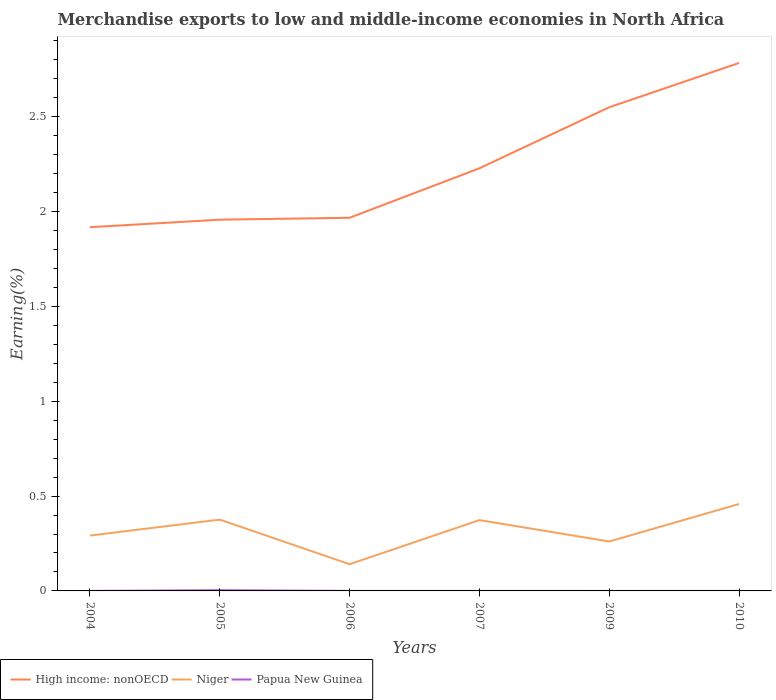Is the number of lines equal to the number of legend labels?
Ensure brevity in your answer.  Yes. Across all years, what is the maximum percentage of amount earned from merchandise exports in High income: nonOECD?
Offer a terse response. 1.92. What is the total percentage of amount earned from merchandise exports in High income: nonOECD in the graph?
Your response must be concise. -0.87. What is the difference between the highest and the second highest percentage of amount earned from merchandise exports in Papua New Guinea?
Your answer should be compact. 0. What is the difference between the highest and the lowest percentage of amount earned from merchandise exports in Niger?
Provide a short and direct response. 3. Is the percentage of amount earned from merchandise exports in Niger strictly greater than the percentage of amount earned from merchandise exports in High income: nonOECD over the years?
Provide a short and direct response. Yes. How many years are there in the graph?
Make the answer very short. 6. Does the graph contain any zero values?
Your answer should be very brief. No. Does the graph contain grids?
Your answer should be very brief. No. How are the legend labels stacked?
Keep it short and to the point. Horizontal. What is the title of the graph?
Give a very brief answer. Merchandise exports to low and middle-income economies in North Africa. What is the label or title of the Y-axis?
Ensure brevity in your answer.  Earning(%). What is the Earning(%) of High income: nonOECD in 2004?
Your answer should be compact. 1.92. What is the Earning(%) of Niger in 2004?
Your response must be concise. 0.29. What is the Earning(%) in Papua New Guinea in 2004?
Keep it short and to the point. 9.77440522683759e-5. What is the Earning(%) of High income: nonOECD in 2005?
Your answer should be very brief. 1.96. What is the Earning(%) of Niger in 2005?
Your response must be concise. 0.38. What is the Earning(%) of Papua New Guinea in 2005?
Your response must be concise. 0. What is the Earning(%) of High income: nonOECD in 2006?
Ensure brevity in your answer.  1.97. What is the Earning(%) in Niger in 2006?
Make the answer very short. 0.14. What is the Earning(%) in Papua New Guinea in 2006?
Offer a very short reply. 5.687845223438829e-5. What is the Earning(%) of High income: nonOECD in 2007?
Offer a terse response. 2.23. What is the Earning(%) in Niger in 2007?
Keep it short and to the point. 0.37. What is the Earning(%) in Papua New Guinea in 2007?
Your answer should be very brief. 7.101729207290841e-5. What is the Earning(%) of High income: nonOECD in 2009?
Offer a terse response. 2.55. What is the Earning(%) of Niger in 2009?
Your response must be concise. 0.26. What is the Earning(%) of Papua New Guinea in 2009?
Your answer should be compact. 2.30290582188182e-5. What is the Earning(%) in High income: nonOECD in 2010?
Your answer should be very brief. 2.78. What is the Earning(%) of Niger in 2010?
Offer a very short reply. 0.46. What is the Earning(%) in Papua New Guinea in 2010?
Offer a very short reply. 3.96869620498379e-5. Across all years, what is the maximum Earning(%) of High income: nonOECD?
Your response must be concise. 2.78. Across all years, what is the maximum Earning(%) of Niger?
Your answer should be very brief. 0.46. Across all years, what is the maximum Earning(%) in Papua New Guinea?
Offer a very short reply. 0. Across all years, what is the minimum Earning(%) in High income: nonOECD?
Your answer should be compact. 1.92. Across all years, what is the minimum Earning(%) of Niger?
Give a very brief answer. 0.14. Across all years, what is the minimum Earning(%) of Papua New Guinea?
Provide a succinct answer. 2.30290582188182e-5. What is the total Earning(%) in High income: nonOECD in the graph?
Provide a succinct answer. 13.4. What is the total Earning(%) of Niger in the graph?
Your answer should be compact. 1.9. What is the total Earning(%) of Papua New Guinea in the graph?
Give a very brief answer. 0. What is the difference between the Earning(%) in High income: nonOECD in 2004 and that in 2005?
Keep it short and to the point. -0.04. What is the difference between the Earning(%) in Niger in 2004 and that in 2005?
Ensure brevity in your answer.  -0.08. What is the difference between the Earning(%) in Papua New Guinea in 2004 and that in 2005?
Make the answer very short. -0. What is the difference between the Earning(%) of High income: nonOECD in 2004 and that in 2006?
Give a very brief answer. -0.05. What is the difference between the Earning(%) in Niger in 2004 and that in 2006?
Provide a short and direct response. 0.15. What is the difference between the Earning(%) of High income: nonOECD in 2004 and that in 2007?
Your answer should be compact. -0.31. What is the difference between the Earning(%) of Niger in 2004 and that in 2007?
Provide a succinct answer. -0.08. What is the difference between the Earning(%) of Papua New Guinea in 2004 and that in 2007?
Provide a succinct answer. 0. What is the difference between the Earning(%) of High income: nonOECD in 2004 and that in 2009?
Offer a terse response. -0.63. What is the difference between the Earning(%) in Niger in 2004 and that in 2009?
Your answer should be very brief. 0.03. What is the difference between the Earning(%) in High income: nonOECD in 2004 and that in 2010?
Your answer should be very brief. -0.87. What is the difference between the Earning(%) of Niger in 2004 and that in 2010?
Offer a terse response. -0.17. What is the difference between the Earning(%) of High income: nonOECD in 2005 and that in 2006?
Provide a succinct answer. -0.01. What is the difference between the Earning(%) in Niger in 2005 and that in 2006?
Give a very brief answer. 0.24. What is the difference between the Earning(%) in Papua New Guinea in 2005 and that in 2006?
Your answer should be compact. 0. What is the difference between the Earning(%) in High income: nonOECD in 2005 and that in 2007?
Your response must be concise. -0.27. What is the difference between the Earning(%) of Niger in 2005 and that in 2007?
Offer a very short reply. 0. What is the difference between the Earning(%) in Papua New Guinea in 2005 and that in 2007?
Keep it short and to the point. 0. What is the difference between the Earning(%) in High income: nonOECD in 2005 and that in 2009?
Ensure brevity in your answer.  -0.59. What is the difference between the Earning(%) in Niger in 2005 and that in 2009?
Your response must be concise. 0.12. What is the difference between the Earning(%) in Papua New Guinea in 2005 and that in 2009?
Offer a terse response. 0. What is the difference between the Earning(%) in High income: nonOECD in 2005 and that in 2010?
Ensure brevity in your answer.  -0.83. What is the difference between the Earning(%) of Niger in 2005 and that in 2010?
Make the answer very short. -0.08. What is the difference between the Earning(%) of Papua New Guinea in 2005 and that in 2010?
Your answer should be very brief. 0. What is the difference between the Earning(%) in High income: nonOECD in 2006 and that in 2007?
Provide a short and direct response. -0.26. What is the difference between the Earning(%) in Niger in 2006 and that in 2007?
Provide a short and direct response. -0.23. What is the difference between the Earning(%) in Papua New Guinea in 2006 and that in 2007?
Ensure brevity in your answer.  -0. What is the difference between the Earning(%) in High income: nonOECD in 2006 and that in 2009?
Your response must be concise. -0.58. What is the difference between the Earning(%) in Niger in 2006 and that in 2009?
Offer a very short reply. -0.12. What is the difference between the Earning(%) of High income: nonOECD in 2006 and that in 2010?
Provide a succinct answer. -0.82. What is the difference between the Earning(%) in Niger in 2006 and that in 2010?
Make the answer very short. -0.32. What is the difference between the Earning(%) in High income: nonOECD in 2007 and that in 2009?
Offer a terse response. -0.32. What is the difference between the Earning(%) of Niger in 2007 and that in 2009?
Ensure brevity in your answer.  0.11. What is the difference between the Earning(%) of High income: nonOECD in 2007 and that in 2010?
Offer a terse response. -0.56. What is the difference between the Earning(%) in Niger in 2007 and that in 2010?
Your response must be concise. -0.08. What is the difference between the Earning(%) in Papua New Guinea in 2007 and that in 2010?
Provide a succinct answer. 0. What is the difference between the Earning(%) in High income: nonOECD in 2009 and that in 2010?
Offer a terse response. -0.23. What is the difference between the Earning(%) of Niger in 2009 and that in 2010?
Offer a very short reply. -0.2. What is the difference between the Earning(%) of High income: nonOECD in 2004 and the Earning(%) of Niger in 2005?
Ensure brevity in your answer.  1.54. What is the difference between the Earning(%) of High income: nonOECD in 2004 and the Earning(%) of Papua New Guinea in 2005?
Your response must be concise. 1.91. What is the difference between the Earning(%) in Niger in 2004 and the Earning(%) in Papua New Guinea in 2005?
Keep it short and to the point. 0.29. What is the difference between the Earning(%) in High income: nonOECD in 2004 and the Earning(%) in Niger in 2006?
Provide a succinct answer. 1.78. What is the difference between the Earning(%) of High income: nonOECD in 2004 and the Earning(%) of Papua New Guinea in 2006?
Ensure brevity in your answer.  1.92. What is the difference between the Earning(%) of Niger in 2004 and the Earning(%) of Papua New Guinea in 2006?
Your response must be concise. 0.29. What is the difference between the Earning(%) in High income: nonOECD in 2004 and the Earning(%) in Niger in 2007?
Make the answer very short. 1.54. What is the difference between the Earning(%) of High income: nonOECD in 2004 and the Earning(%) of Papua New Guinea in 2007?
Your answer should be very brief. 1.92. What is the difference between the Earning(%) of Niger in 2004 and the Earning(%) of Papua New Guinea in 2007?
Ensure brevity in your answer.  0.29. What is the difference between the Earning(%) in High income: nonOECD in 2004 and the Earning(%) in Niger in 2009?
Offer a very short reply. 1.66. What is the difference between the Earning(%) in High income: nonOECD in 2004 and the Earning(%) in Papua New Guinea in 2009?
Keep it short and to the point. 1.92. What is the difference between the Earning(%) of Niger in 2004 and the Earning(%) of Papua New Guinea in 2009?
Make the answer very short. 0.29. What is the difference between the Earning(%) of High income: nonOECD in 2004 and the Earning(%) of Niger in 2010?
Your response must be concise. 1.46. What is the difference between the Earning(%) of High income: nonOECD in 2004 and the Earning(%) of Papua New Guinea in 2010?
Provide a succinct answer. 1.92. What is the difference between the Earning(%) of Niger in 2004 and the Earning(%) of Papua New Guinea in 2010?
Your response must be concise. 0.29. What is the difference between the Earning(%) of High income: nonOECD in 2005 and the Earning(%) of Niger in 2006?
Your answer should be very brief. 1.82. What is the difference between the Earning(%) in High income: nonOECD in 2005 and the Earning(%) in Papua New Guinea in 2006?
Your answer should be compact. 1.96. What is the difference between the Earning(%) in Niger in 2005 and the Earning(%) in Papua New Guinea in 2006?
Ensure brevity in your answer.  0.38. What is the difference between the Earning(%) of High income: nonOECD in 2005 and the Earning(%) of Niger in 2007?
Provide a short and direct response. 1.58. What is the difference between the Earning(%) in High income: nonOECD in 2005 and the Earning(%) in Papua New Guinea in 2007?
Keep it short and to the point. 1.96. What is the difference between the Earning(%) in Niger in 2005 and the Earning(%) in Papua New Guinea in 2007?
Your answer should be compact. 0.38. What is the difference between the Earning(%) of High income: nonOECD in 2005 and the Earning(%) of Niger in 2009?
Offer a very short reply. 1.7. What is the difference between the Earning(%) of High income: nonOECD in 2005 and the Earning(%) of Papua New Guinea in 2009?
Provide a short and direct response. 1.96. What is the difference between the Earning(%) in Niger in 2005 and the Earning(%) in Papua New Guinea in 2009?
Offer a terse response. 0.38. What is the difference between the Earning(%) in High income: nonOECD in 2005 and the Earning(%) in Niger in 2010?
Provide a succinct answer. 1.5. What is the difference between the Earning(%) in High income: nonOECD in 2005 and the Earning(%) in Papua New Guinea in 2010?
Make the answer very short. 1.96. What is the difference between the Earning(%) in Niger in 2005 and the Earning(%) in Papua New Guinea in 2010?
Your answer should be very brief. 0.38. What is the difference between the Earning(%) in High income: nonOECD in 2006 and the Earning(%) in Niger in 2007?
Give a very brief answer. 1.59. What is the difference between the Earning(%) of High income: nonOECD in 2006 and the Earning(%) of Papua New Guinea in 2007?
Provide a succinct answer. 1.97. What is the difference between the Earning(%) of Niger in 2006 and the Earning(%) of Papua New Guinea in 2007?
Offer a terse response. 0.14. What is the difference between the Earning(%) in High income: nonOECD in 2006 and the Earning(%) in Niger in 2009?
Ensure brevity in your answer.  1.71. What is the difference between the Earning(%) in High income: nonOECD in 2006 and the Earning(%) in Papua New Guinea in 2009?
Keep it short and to the point. 1.97. What is the difference between the Earning(%) of Niger in 2006 and the Earning(%) of Papua New Guinea in 2009?
Offer a terse response. 0.14. What is the difference between the Earning(%) in High income: nonOECD in 2006 and the Earning(%) in Niger in 2010?
Give a very brief answer. 1.51. What is the difference between the Earning(%) in High income: nonOECD in 2006 and the Earning(%) in Papua New Guinea in 2010?
Offer a very short reply. 1.97. What is the difference between the Earning(%) in Niger in 2006 and the Earning(%) in Papua New Guinea in 2010?
Give a very brief answer. 0.14. What is the difference between the Earning(%) in High income: nonOECD in 2007 and the Earning(%) in Niger in 2009?
Offer a terse response. 1.97. What is the difference between the Earning(%) of High income: nonOECD in 2007 and the Earning(%) of Papua New Guinea in 2009?
Make the answer very short. 2.23. What is the difference between the Earning(%) in Niger in 2007 and the Earning(%) in Papua New Guinea in 2009?
Ensure brevity in your answer.  0.37. What is the difference between the Earning(%) in High income: nonOECD in 2007 and the Earning(%) in Niger in 2010?
Offer a terse response. 1.77. What is the difference between the Earning(%) of High income: nonOECD in 2007 and the Earning(%) of Papua New Guinea in 2010?
Keep it short and to the point. 2.23. What is the difference between the Earning(%) in Niger in 2007 and the Earning(%) in Papua New Guinea in 2010?
Provide a short and direct response. 0.37. What is the difference between the Earning(%) of High income: nonOECD in 2009 and the Earning(%) of Niger in 2010?
Your response must be concise. 2.09. What is the difference between the Earning(%) in High income: nonOECD in 2009 and the Earning(%) in Papua New Guinea in 2010?
Your response must be concise. 2.55. What is the difference between the Earning(%) in Niger in 2009 and the Earning(%) in Papua New Guinea in 2010?
Make the answer very short. 0.26. What is the average Earning(%) of High income: nonOECD per year?
Offer a terse response. 2.23. What is the average Earning(%) in Niger per year?
Provide a short and direct response. 0.32. What is the average Earning(%) in Papua New Guinea per year?
Provide a short and direct response. 0. In the year 2004, what is the difference between the Earning(%) of High income: nonOECD and Earning(%) of Niger?
Give a very brief answer. 1.63. In the year 2004, what is the difference between the Earning(%) in High income: nonOECD and Earning(%) in Papua New Guinea?
Give a very brief answer. 1.92. In the year 2004, what is the difference between the Earning(%) in Niger and Earning(%) in Papua New Guinea?
Ensure brevity in your answer.  0.29. In the year 2005, what is the difference between the Earning(%) of High income: nonOECD and Earning(%) of Niger?
Your answer should be compact. 1.58. In the year 2005, what is the difference between the Earning(%) of High income: nonOECD and Earning(%) of Papua New Guinea?
Provide a short and direct response. 1.95. In the year 2005, what is the difference between the Earning(%) in Niger and Earning(%) in Papua New Guinea?
Make the answer very short. 0.37. In the year 2006, what is the difference between the Earning(%) of High income: nonOECD and Earning(%) of Niger?
Your answer should be very brief. 1.83. In the year 2006, what is the difference between the Earning(%) of High income: nonOECD and Earning(%) of Papua New Guinea?
Provide a succinct answer. 1.97. In the year 2006, what is the difference between the Earning(%) of Niger and Earning(%) of Papua New Guinea?
Provide a succinct answer. 0.14. In the year 2007, what is the difference between the Earning(%) of High income: nonOECD and Earning(%) of Niger?
Provide a succinct answer. 1.85. In the year 2007, what is the difference between the Earning(%) of High income: nonOECD and Earning(%) of Papua New Guinea?
Ensure brevity in your answer.  2.23. In the year 2007, what is the difference between the Earning(%) of Niger and Earning(%) of Papua New Guinea?
Provide a succinct answer. 0.37. In the year 2009, what is the difference between the Earning(%) in High income: nonOECD and Earning(%) in Niger?
Provide a short and direct response. 2.29. In the year 2009, what is the difference between the Earning(%) in High income: nonOECD and Earning(%) in Papua New Guinea?
Your answer should be compact. 2.55. In the year 2009, what is the difference between the Earning(%) of Niger and Earning(%) of Papua New Guinea?
Your response must be concise. 0.26. In the year 2010, what is the difference between the Earning(%) in High income: nonOECD and Earning(%) in Niger?
Provide a short and direct response. 2.33. In the year 2010, what is the difference between the Earning(%) of High income: nonOECD and Earning(%) of Papua New Guinea?
Offer a terse response. 2.78. In the year 2010, what is the difference between the Earning(%) of Niger and Earning(%) of Papua New Guinea?
Your response must be concise. 0.46. What is the ratio of the Earning(%) in High income: nonOECD in 2004 to that in 2005?
Provide a succinct answer. 0.98. What is the ratio of the Earning(%) of Niger in 2004 to that in 2005?
Ensure brevity in your answer.  0.78. What is the ratio of the Earning(%) of Papua New Guinea in 2004 to that in 2005?
Make the answer very short. 0.02. What is the ratio of the Earning(%) in High income: nonOECD in 2004 to that in 2006?
Offer a terse response. 0.97. What is the ratio of the Earning(%) of Niger in 2004 to that in 2006?
Offer a very short reply. 2.07. What is the ratio of the Earning(%) in Papua New Guinea in 2004 to that in 2006?
Ensure brevity in your answer.  1.72. What is the ratio of the Earning(%) in High income: nonOECD in 2004 to that in 2007?
Give a very brief answer. 0.86. What is the ratio of the Earning(%) of Niger in 2004 to that in 2007?
Your answer should be very brief. 0.78. What is the ratio of the Earning(%) in Papua New Guinea in 2004 to that in 2007?
Your answer should be compact. 1.38. What is the ratio of the Earning(%) in High income: nonOECD in 2004 to that in 2009?
Make the answer very short. 0.75. What is the ratio of the Earning(%) of Niger in 2004 to that in 2009?
Your response must be concise. 1.12. What is the ratio of the Earning(%) of Papua New Guinea in 2004 to that in 2009?
Offer a terse response. 4.24. What is the ratio of the Earning(%) in High income: nonOECD in 2004 to that in 2010?
Your response must be concise. 0.69. What is the ratio of the Earning(%) in Niger in 2004 to that in 2010?
Give a very brief answer. 0.64. What is the ratio of the Earning(%) of Papua New Guinea in 2004 to that in 2010?
Offer a terse response. 2.46. What is the ratio of the Earning(%) of Niger in 2005 to that in 2006?
Your answer should be very brief. 2.67. What is the ratio of the Earning(%) of Papua New Guinea in 2005 to that in 2006?
Your response must be concise. 69.36. What is the ratio of the Earning(%) of High income: nonOECD in 2005 to that in 2007?
Your response must be concise. 0.88. What is the ratio of the Earning(%) of Niger in 2005 to that in 2007?
Offer a terse response. 1.01. What is the ratio of the Earning(%) in Papua New Guinea in 2005 to that in 2007?
Provide a succinct answer. 55.55. What is the ratio of the Earning(%) in High income: nonOECD in 2005 to that in 2009?
Ensure brevity in your answer.  0.77. What is the ratio of the Earning(%) in Niger in 2005 to that in 2009?
Provide a short and direct response. 1.44. What is the ratio of the Earning(%) of Papua New Guinea in 2005 to that in 2009?
Give a very brief answer. 171.3. What is the ratio of the Earning(%) of High income: nonOECD in 2005 to that in 2010?
Provide a short and direct response. 0.7. What is the ratio of the Earning(%) of Niger in 2005 to that in 2010?
Offer a very short reply. 0.82. What is the ratio of the Earning(%) in Papua New Guinea in 2005 to that in 2010?
Keep it short and to the point. 99.4. What is the ratio of the Earning(%) in High income: nonOECD in 2006 to that in 2007?
Your answer should be compact. 0.88. What is the ratio of the Earning(%) in Niger in 2006 to that in 2007?
Provide a succinct answer. 0.38. What is the ratio of the Earning(%) in Papua New Guinea in 2006 to that in 2007?
Your answer should be compact. 0.8. What is the ratio of the Earning(%) in High income: nonOECD in 2006 to that in 2009?
Your answer should be compact. 0.77. What is the ratio of the Earning(%) in Niger in 2006 to that in 2009?
Offer a very short reply. 0.54. What is the ratio of the Earning(%) of Papua New Guinea in 2006 to that in 2009?
Offer a terse response. 2.47. What is the ratio of the Earning(%) in High income: nonOECD in 2006 to that in 2010?
Your answer should be compact. 0.71. What is the ratio of the Earning(%) of Niger in 2006 to that in 2010?
Offer a very short reply. 0.31. What is the ratio of the Earning(%) of Papua New Guinea in 2006 to that in 2010?
Ensure brevity in your answer.  1.43. What is the ratio of the Earning(%) of High income: nonOECD in 2007 to that in 2009?
Offer a very short reply. 0.87. What is the ratio of the Earning(%) of Niger in 2007 to that in 2009?
Your response must be concise. 1.43. What is the ratio of the Earning(%) in Papua New Guinea in 2007 to that in 2009?
Provide a short and direct response. 3.08. What is the ratio of the Earning(%) of High income: nonOECD in 2007 to that in 2010?
Ensure brevity in your answer.  0.8. What is the ratio of the Earning(%) in Niger in 2007 to that in 2010?
Your response must be concise. 0.81. What is the ratio of the Earning(%) of Papua New Guinea in 2007 to that in 2010?
Give a very brief answer. 1.79. What is the ratio of the Earning(%) of High income: nonOECD in 2009 to that in 2010?
Keep it short and to the point. 0.92. What is the ratio of the Earning(%) in Niger in 2009 to that in 2010?
Ensure brevity in your answer.  0.57. What is the ratio of the Earning(%) in Papua New Guinea in 2009 to that in 2010?
Offer a very short reply. 0.58. What is the difference between the highest and the second highest Earning(%) in High income: nonOECD?
Keep it short and to the point. 0.23. What is the difference between the highest and the second highest Earning(%) of Niger?
Your answer should be very brief. 0.08. What is the difference between the highest and the second highest Earning(%) in Papua New Guinea?
Provide a succinct answer. 0. What is the difference between the highest and the lowest Earning(%) of High income: nonOECD?
Your answer should be very brief. 0.87. What is the difference between the highest and the lowest Earning(%) of Niger?
Offer a terse response. 0.32. What is the difference between the highest and the lowest Earning(%) in Papua New Guinea?
Give a very brief answer. 0. 